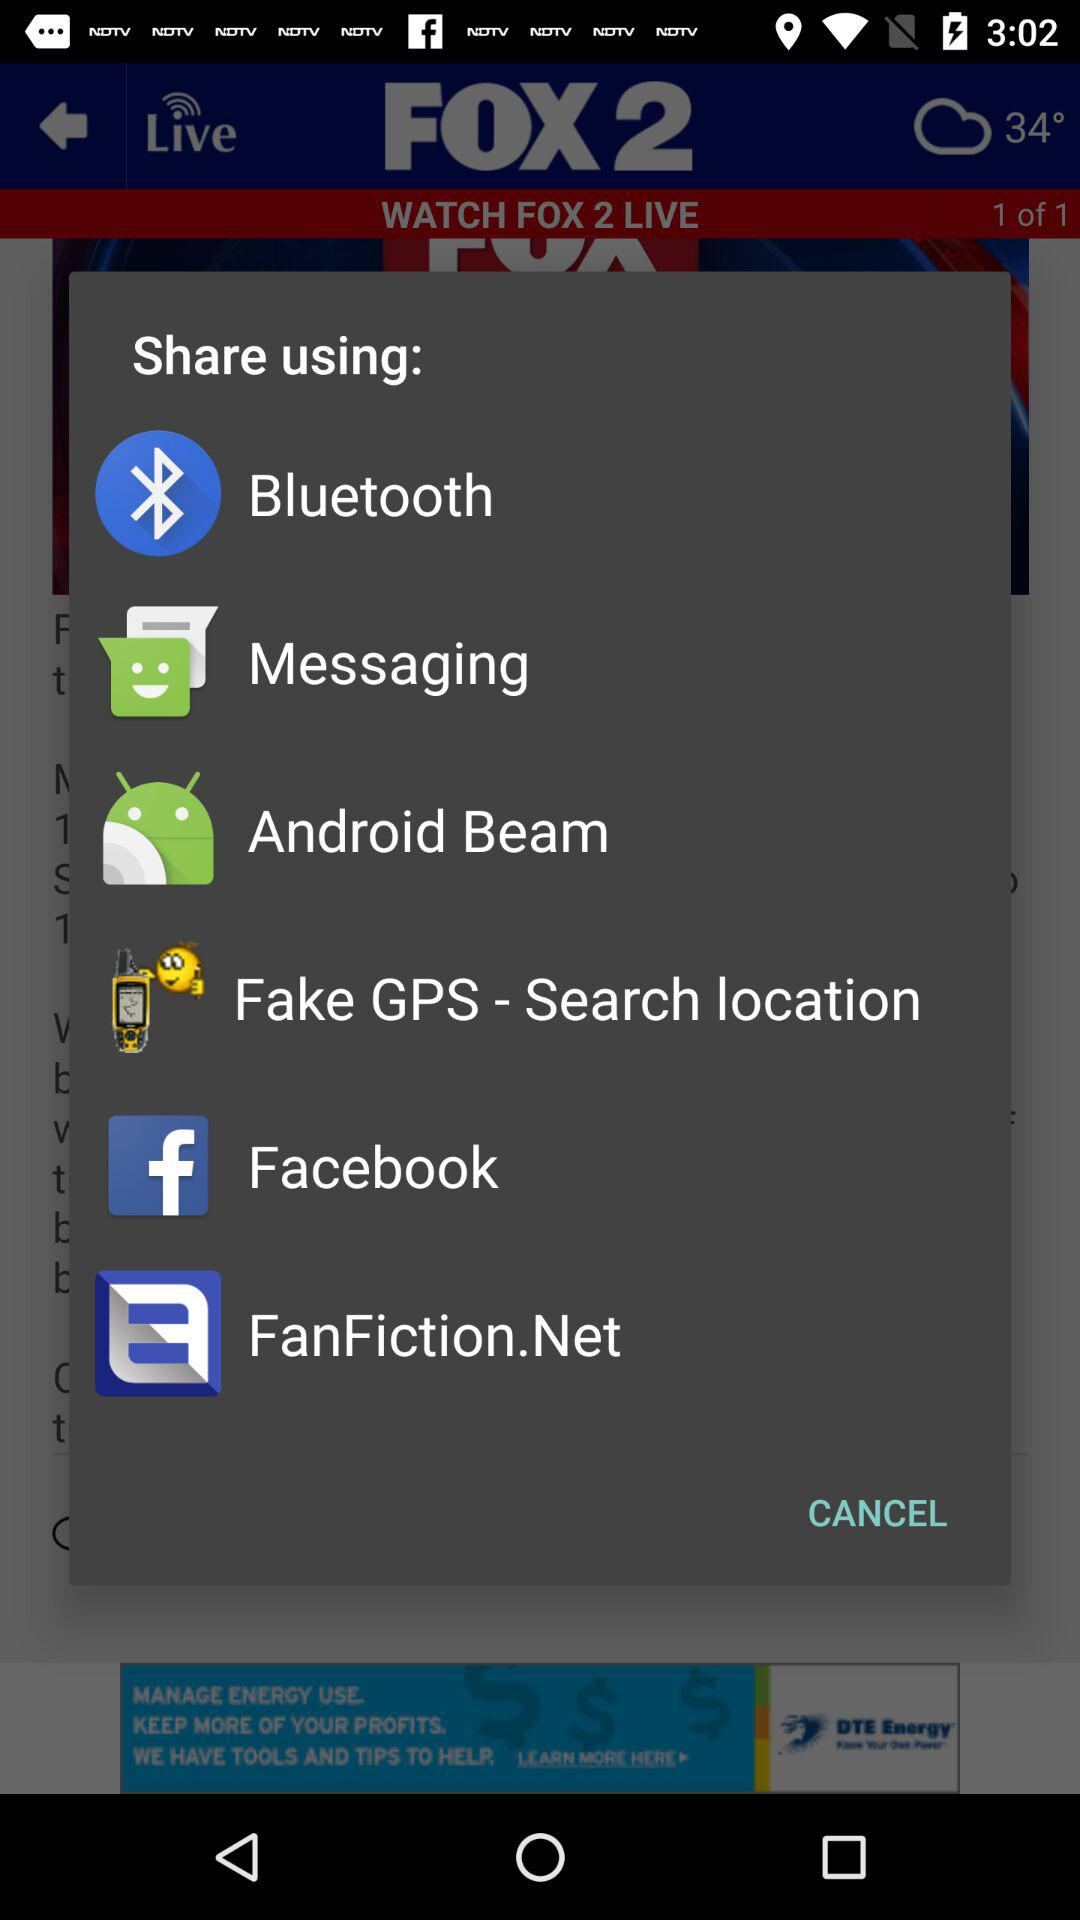How many items are on the share menu?
Answer the question using a single word or phrase. 6 